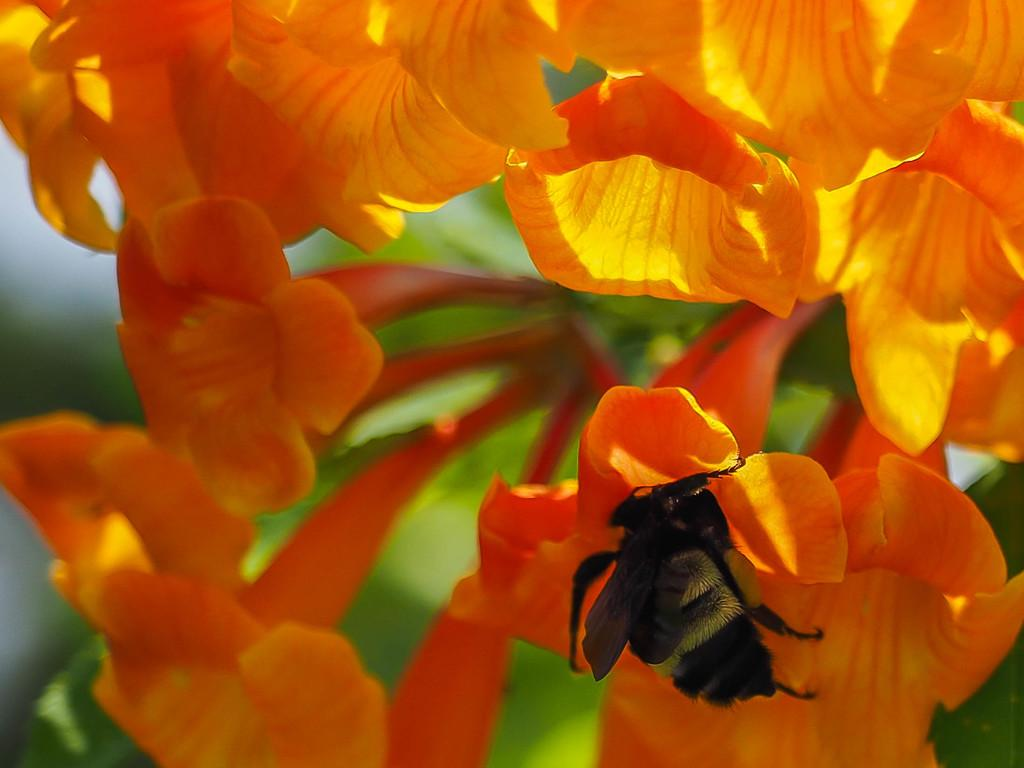What type of plants can be seen in the image? There are flowers in the image. What is the color of the flowers? The flowers are orange in color. Is there any other living creature visible in the image? Yes, there is a bee on one of the flowers. What can be seen in the background of the image? There are green leaves in the background of the image. What type of eggs can be seen in the image? There are no eggs present in the image; it features flowers, a bee, and green leaves. 